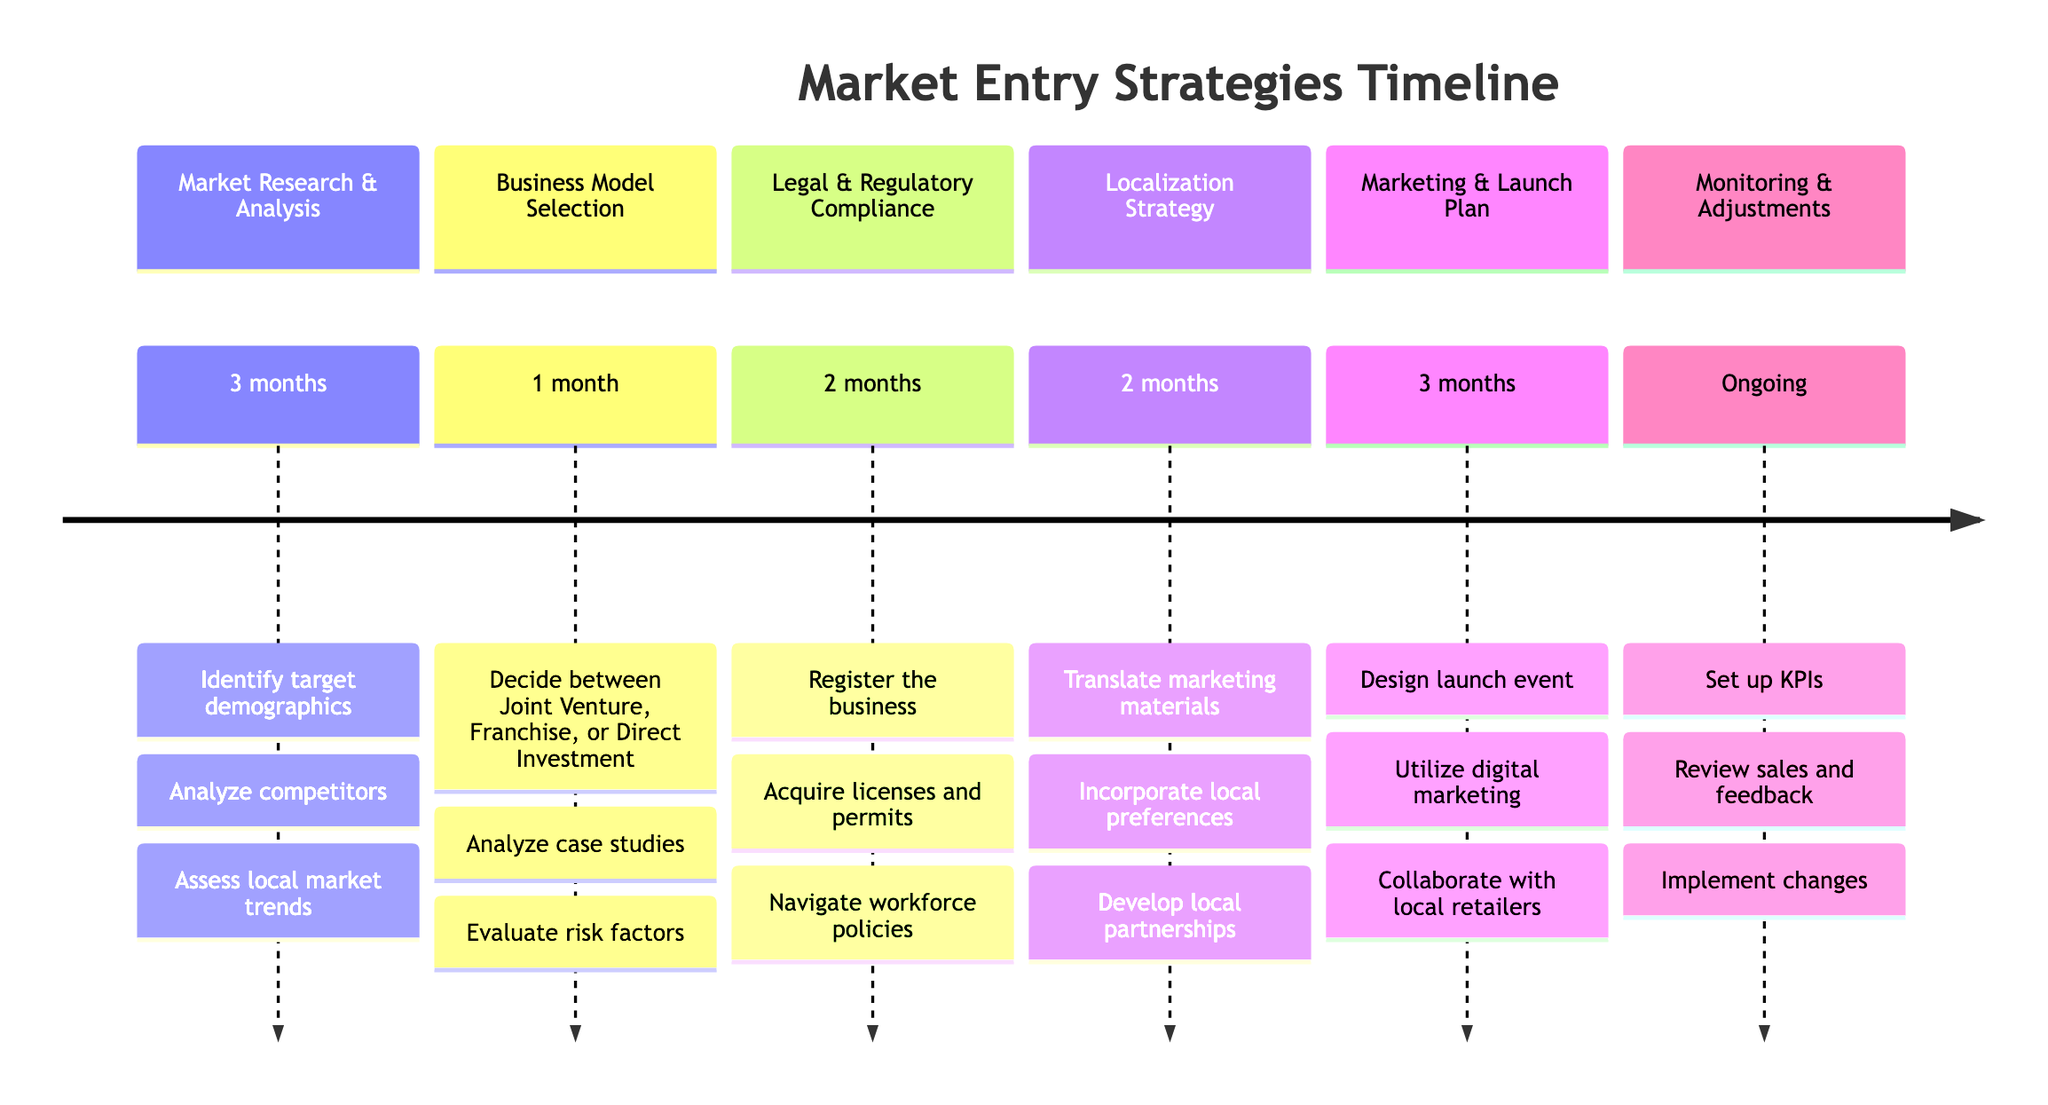What is the duration of the Localization Strategy milestone? The Localization Strategy has a specified duration of 2 months, which is directly indicated in the timeline.
Answer: 2 months What is the last milestone listed in the timeline? The last milestone in the timeline sequence is "Monitoring & Adjustments," which can be found at the end of the listed sections.
Answer: Monitoring & Adjustments How many months are allocated to the Marketing & Launch Plan? The timeline specifies that the Marketing & Launch Plan takes 3 months to complete, which is clearly marked under its respective section.
Answer: 3 months Which milestone requires in-depth market research? The "Market Research & Analysis" milestone focuses on conducting in-depth research to understand consumer behavior, thus leading its section title.
Answer: Market Research & Analysis What are the key decisions made during the Legal & Regulatory Compliance phase? The Legal & Regulatory Compliance section lists three key decisions: Register the business with local authorities, Acquire necessary licenses and permits, and Navigate workforce policies, which are all clearly stated.
Answer: Register the business, Acquire licenses and permits, Navigate workforce policies What milestone follows after Business Model Selection? The milestone that follows Business Model Selection in the timeline is "Legal & Regulatory Compliance," sequentially shown directly after the Business Model selection section.
Answer: Legal & Regulatory Compliance How many key decisions are outlined for the Marketing & Launch Plan? The Marketing & Launch Plan details three key decisions to be made: Design a launch event or promotional campaign, Utilize digital marketing channels, and Collaborate with local retail chains, which are explicitly mentioned.
Answer: 3 Which milestone has the longest duration? The milestones with the longest duration (3 months) are "Market Research & Analysis" and "Marketing & Launch Plan," making them the sections with the maximum time allocation in the timeline.
Answer: Market Research & Analysis, Marketing & Launch Plan 